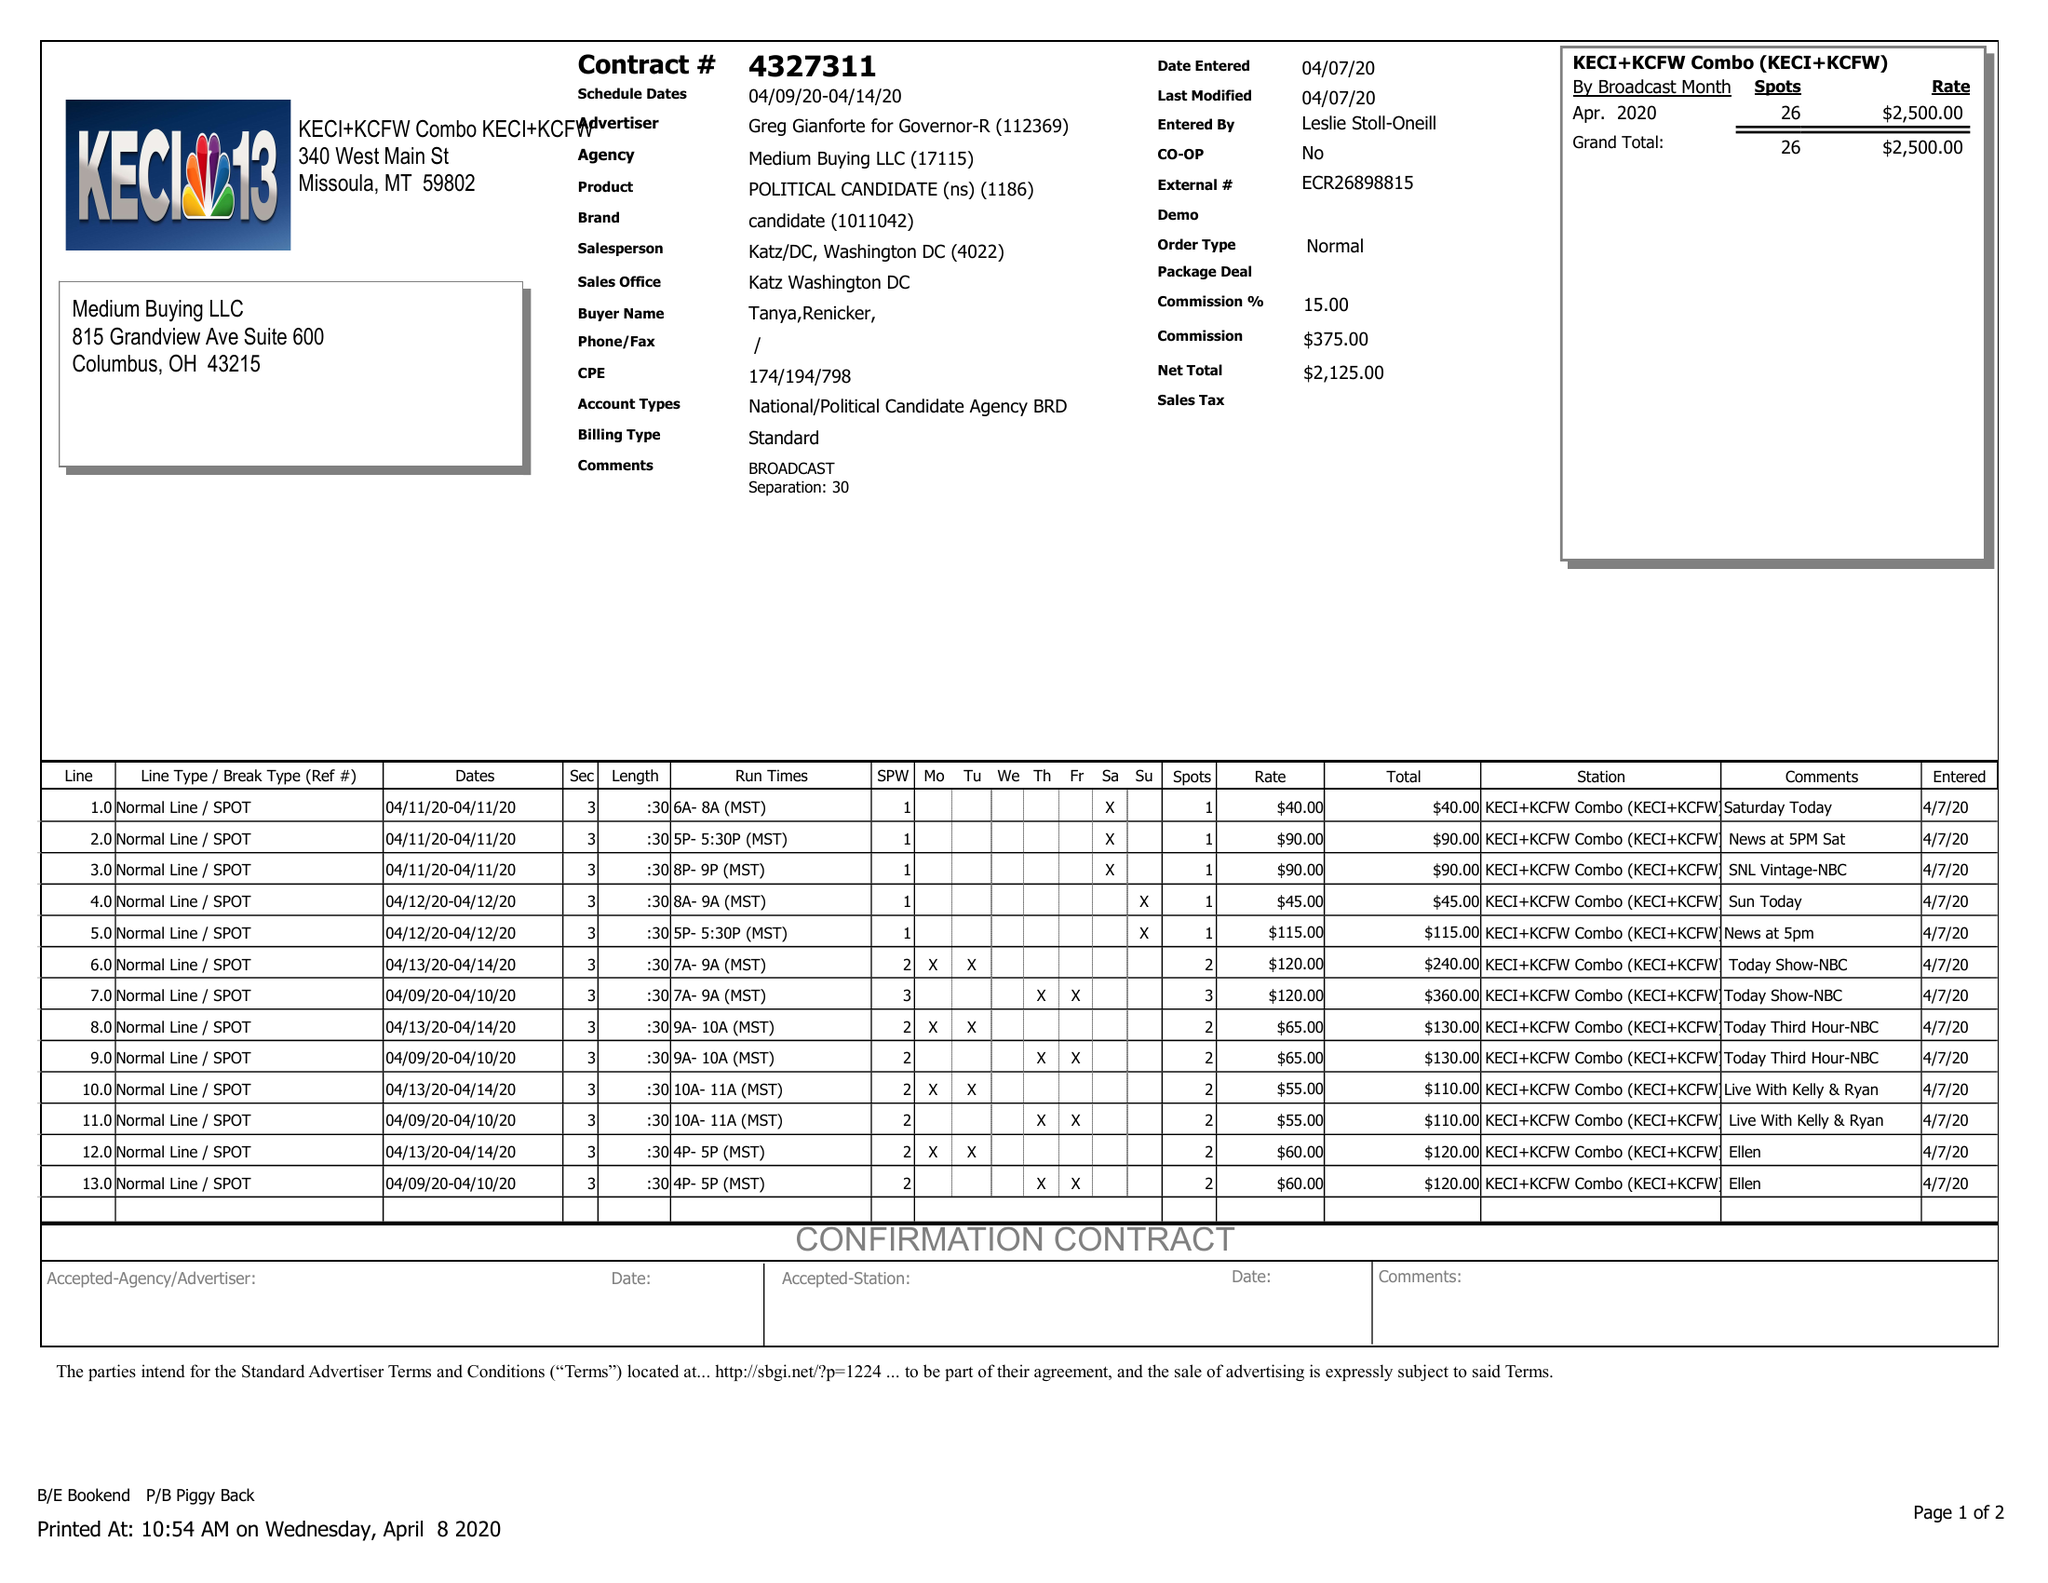What is the value for the flight_to?
Answer the question using a single word or phrase. 04/14/20 